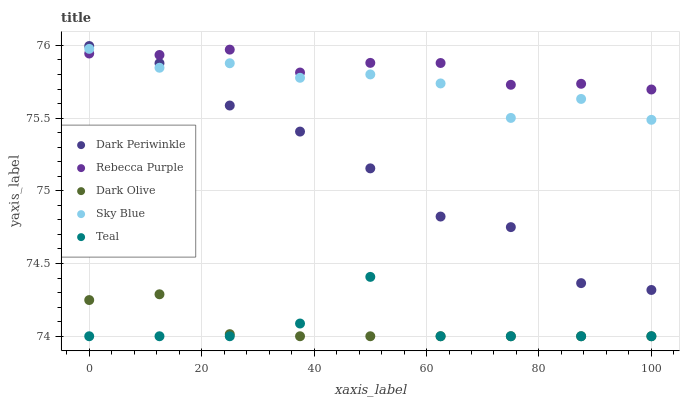Does Dark Olive have the minimum area under the curve?
Answer yes or no. Yes. Does Rebecca Purple have the maximum area under the curve?
Answer yes or no. Yes. Does Dark Periwinkle have the minimum area under the curve?
Answer yes or no. No. Does Dark Periwinkle have the maximum area under the curve?
Answer yes or no. No. Is Dark Olive the smoothest?
Answer yes or no. Yes. Is Teal the roughest?
Answer yes or no. Yes. Is Dark Periwinkle the smoothest?
Answer yes or no. No. Is Dark Periwinkle the roughest?
Answer yes or no. No. Does Dark Olive have the lowest value?
Answer yes or no. Yes. Does Dark Periwinkle have the lowest value?
Answer yes or no. No. Does Dark Periwinkle have the highest value?
Answer yes or no. Yes. Does Dark Olive have the highest value?
Answer yes or no. No. Is Teal less than Rebecca Purple?
Answer yes or no. Yes. Is Rebecca Purple greater than Dark Olive?
Answer yes or no. Yes. Does Teal intersect Dark Olive?
Answer yes or no. Yes. Is Teal less than Dark Olive?
Answer yes or no. No. Is Teal greater than Dark Olive?
Answer yes or no. No. Does Teal intersect Rebecca Purple?
Answer yes or no. No. 